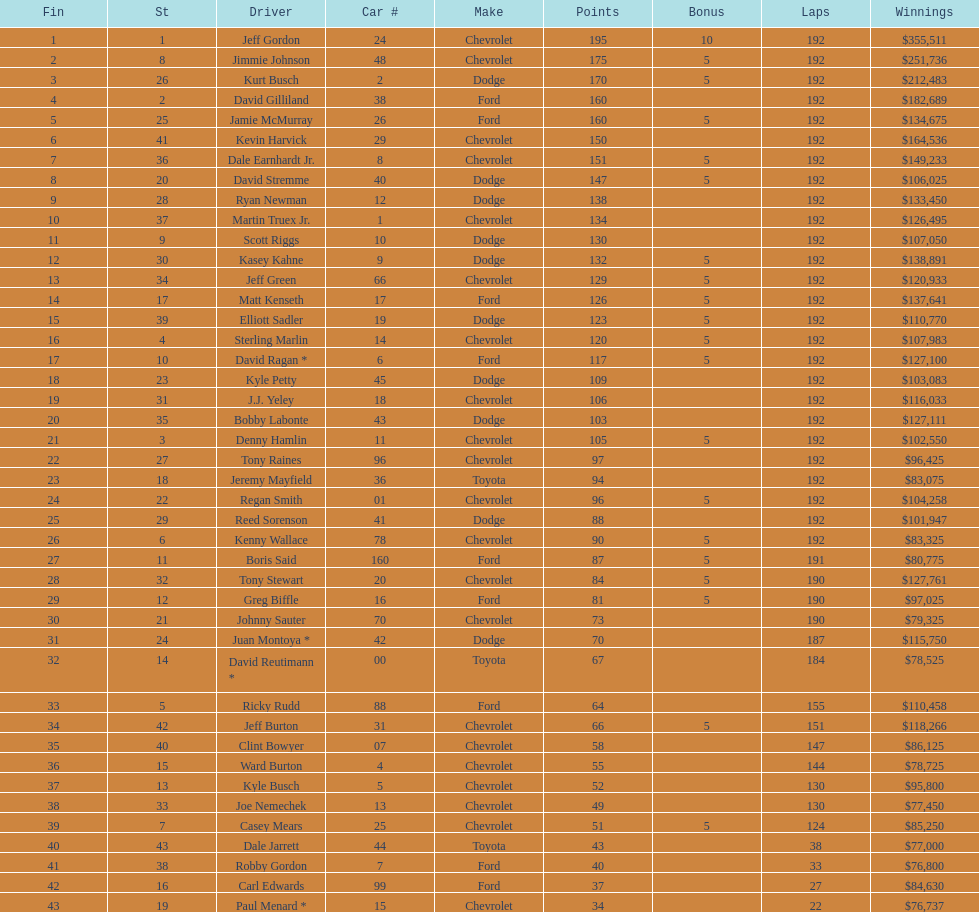What driver earned the least amount of winnings? Paul Menard *. 